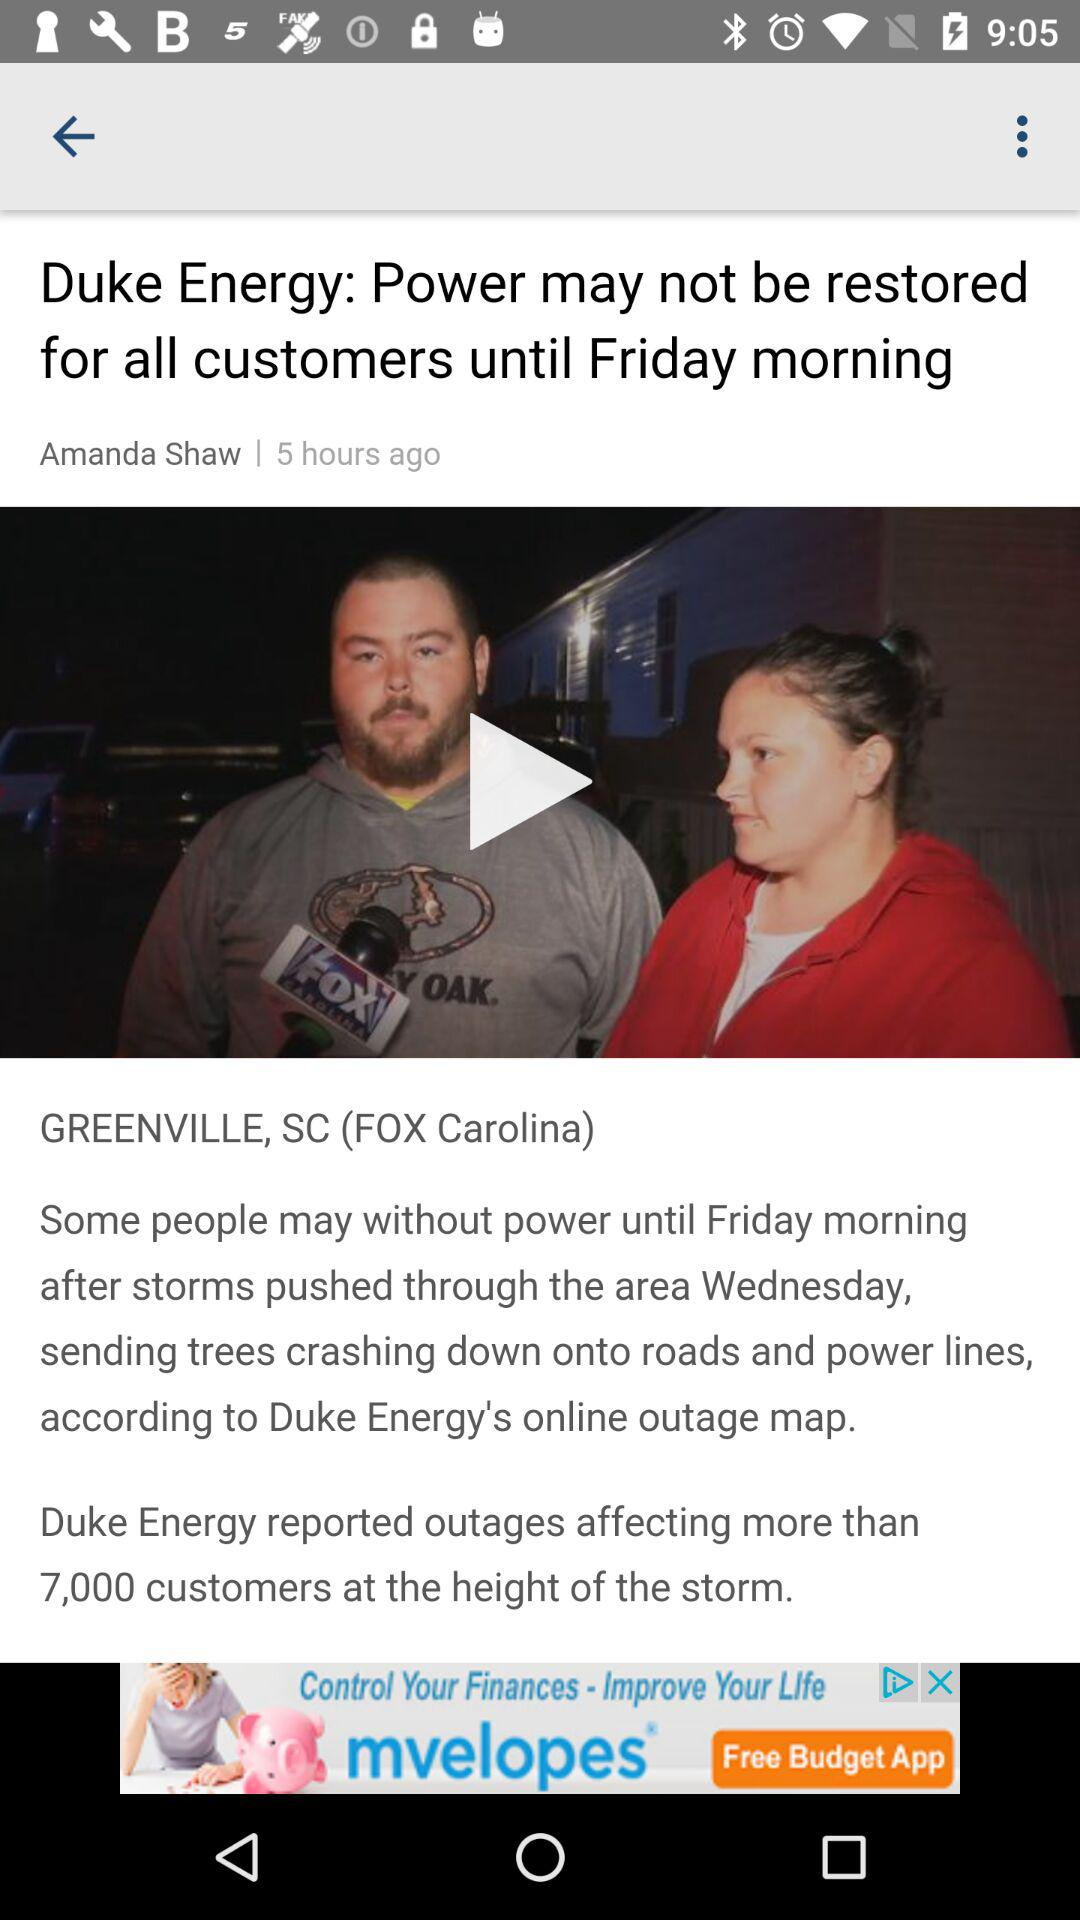How many customers are affected due to the storm outage? The number of affected customers due to the storm outage is more than 7000. 